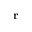Convert formula to latex. <formula><loc_0><loc_0><loc_500><loc_500>r</formula> 